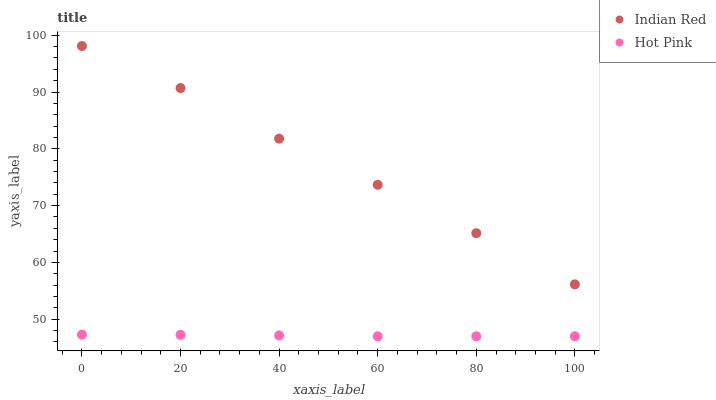Does Hot Pink have the minimum area under the curve?
Answer yes or no. Yes. Does Indian Red have the maximum area under the curve?
Answer yes or no. Yes. Does Indian Red have the minimum area under the curve?
Answer yes or no. No. Is Hot Pink the smoothest?
Answer yes or no. Yes. Is Indian Red the roughest?
Answer yes or no. Yes. Is Indian Red the smoothest?
Answer yes or no. No. Does Hot Pink have the lowest value?
Answer yes or no. Yes. Does Indian Red have the lowest value?
Answer yes or no. No. Does Indian Red have the highest value?
Answer yes or no. Yes. Is Hot Pink less than Indian Red?
Answer yes or no. Yes. Is Indian Red greater than Hot Pink?
Answer yes or no. Yes. Does Hot Pink intersect Indian Red?
Answer yes or no. No. 